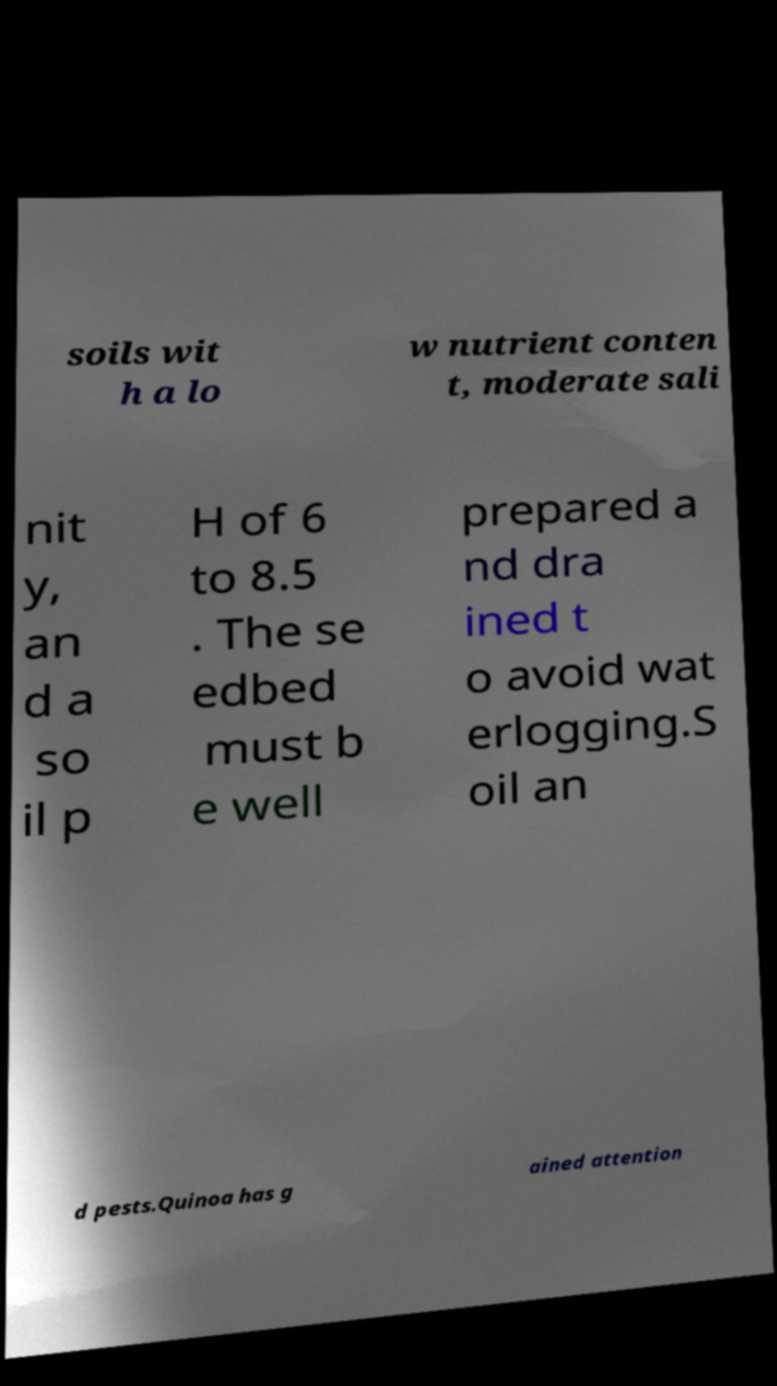For documentation purposes, I need the text within this image transcribed. Could you provide that? soils wit h a lo w nutrient conten t, moderate sali nit y, an d a so il p H of 6 to 8.5 . The se edbed must b e well prepared a nd dra ined t o avoid wat erlogging.S oil an d pests.Quinoa has g ained attention 